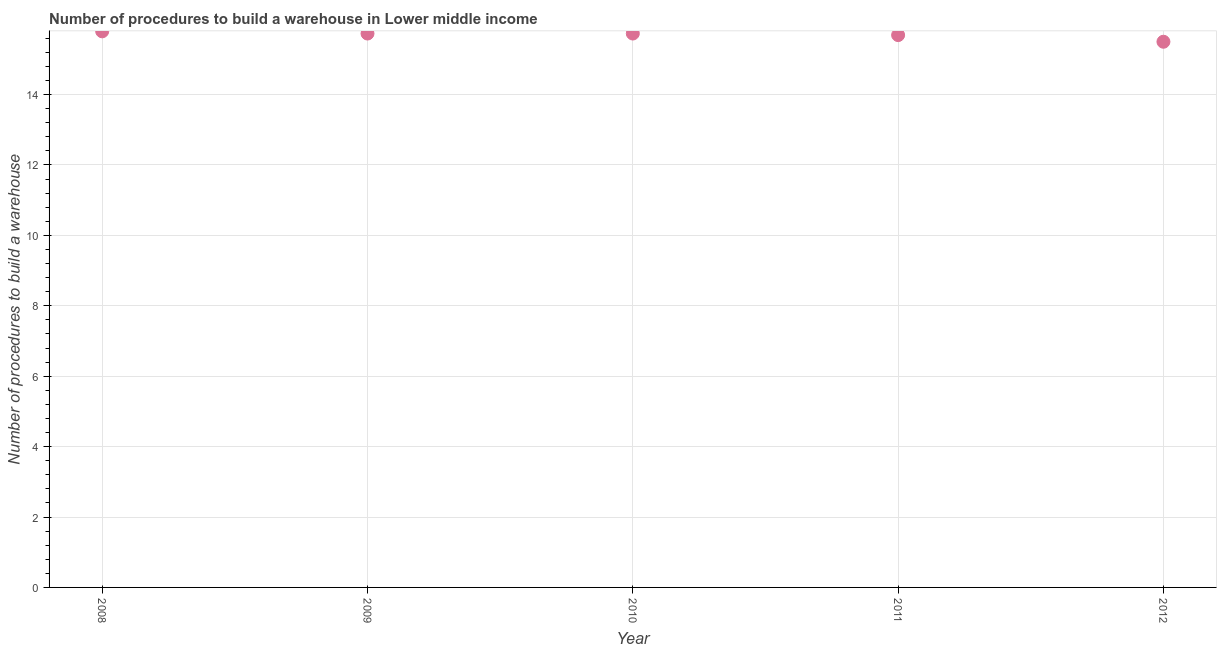What is the number of procedures to build a warehouse in 2010?
Provide a succinct answer. 15.73. Across all years, what is the maximum number of procedures to build a warehouse?
Keep it short and to the point. 15.8. Across all years, what is the minimum number of procedures to build a warehouse?
Provide a succinct answer. 15.5. In which year was the number of procedures to build a warehouse minimum?
Your answer should be compact. 2012. What is the sum of the number of procedures to build a warehouse?
Ensure brevity in your answer.  78.45. What is the difference between the number of procedures to build a warehouse in 2008 and 2010?
Offer a very short reply. 0.06. What is the average number of procedures to build a warehouse per year?
Your answer should be compact. 15.69. What is the median number of procedures to build a warehouse?
Give a very brief answer. 15.73. In how many years, is the number of procedures to build a warehouse greater than 9.2 ?
Offer a terse response. 5. What is the ratio of the number of procedures to build a warehouse in 2011 to that in 2012?
Your answer should be very brief. 1.01. Is the number of procedures to build a warehouse in 2008 less than that in 2009?
Offer a very short reply. No. What is the difference between the highest and the second highest number of procedures to build a warehouse?
Provide a succinct answer. 0.06. Is the sum of the number of procedures to build a warehouse in 2009 and 2010 greater than the maximum number of procedures to build a warehouse across all years?
Your answer should be compact. Yes. What is the difference between the highest and the lowest number of procedures to build a warehouse?
Provide a succinct answer. 0.3. In how many years, is the number of procedures to build a warehouse greater than the average number of procedures to build a warehouse taken over all years?
Ensure brevity in your answer.  3. Does the number of procedures to build a warehouse monotonically increase over the years?
Keep it short and to the point. No. How many years are there in the graph?
Offer a very short reply. 5. Does the graph contain grids?
Ensure brevity in your answer.  Yes. What is the title of the graph?
Make the answer very short. Number of procedures to build a warehouse in Lower middle income. What is the label or title of the Y-axis?
Ensure brevity in your answer.  Number of procedures to build a warehouse. What is the Number of procedures to build a warehouse in 2008?
Provide a short and direct response. 15.8. What is the Number of procedures to build a warehouse in 2009?
Offer a very short reply. 15.73. What is the Number of procedures to build a warehouse in 2010?
Provide a short and direct response. 15.73. What is the Number of procedures to build a warehouse in 2011?
Ensure brevity in your answer.  15.69. What is the difference between the Number of procedures to build a warehouse in 2008 and 2009?
Keep it short and to the point. 0.06. What is the difference between the Number of procedures to build a warehouse in 2008 and 2010?
Offer a terse response. 0.06. What is the difference between the Number of procedures to build a warehouse in 2008 and 2011?
Your response must be concise. 0.11. What is the difference between the Number of procedures to build a warehouse in 2008 and 2012?
Make the answer very short. 0.3. What is the difference between the Number of procedures to build a warehouse in 2009 and 2011?
Your response must be concise. 0.04. What is the difference between the Number of procedures to build a warehouse in 2009 and 2012?
Your response must be concise. 0.23. What is the difference between the Number of procedures to build a warehouse in 2010 and 2011?
Your answer should be compact. 0.04. What is the difference between the Number of procedures to build a warehouse in 2010 and 2012?
Give a very brief answer. 0.23. What is the difference between the Number of procedures to build a warehouse in 2011 and 2012?
Offer a very short reply. 0.19. What is the ratio of the Number of procedures to build a warehouse in 2008 to that in 2009?
Ensure brevity in your answer.  1. What is the ratio of the Number of procedures to build a warehouse in 2008 to that in 2010?
Your answer should be compact. 1. What is the ratio of the Number of procedures to build a warehouse in 2008 to that in 2011?
Offer a terse response. 1.01. What is the ratio of the Number of procedures to build a warehouse in 2009 to that in 2010?
Provide a succinct answer. 1. What is the ratio of the Number of procedures to build a warehouse in 2010 to that in 2011?
Your answer should be very brief. 1. What is the ratio of the Number of procedures to build a warehouse in 2011 to that in 2012?
Offer a very short reply. 1.01. 